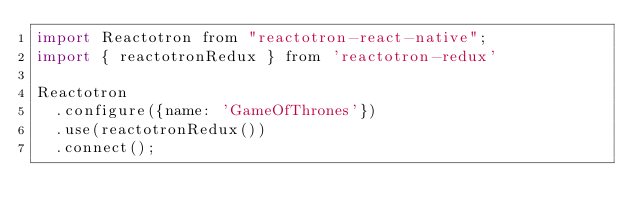<code> <loc_0><loc_0><loc_500><loc_500><_JavaScript_>import Reactotron from "reactotron-react-native";
import { reactotronRedux } from 'reactotron-redux'

Reactotron
  .configure({name: 'GameOfThrones'})
  .use(reactotronRedux())
  .connect();</code> 